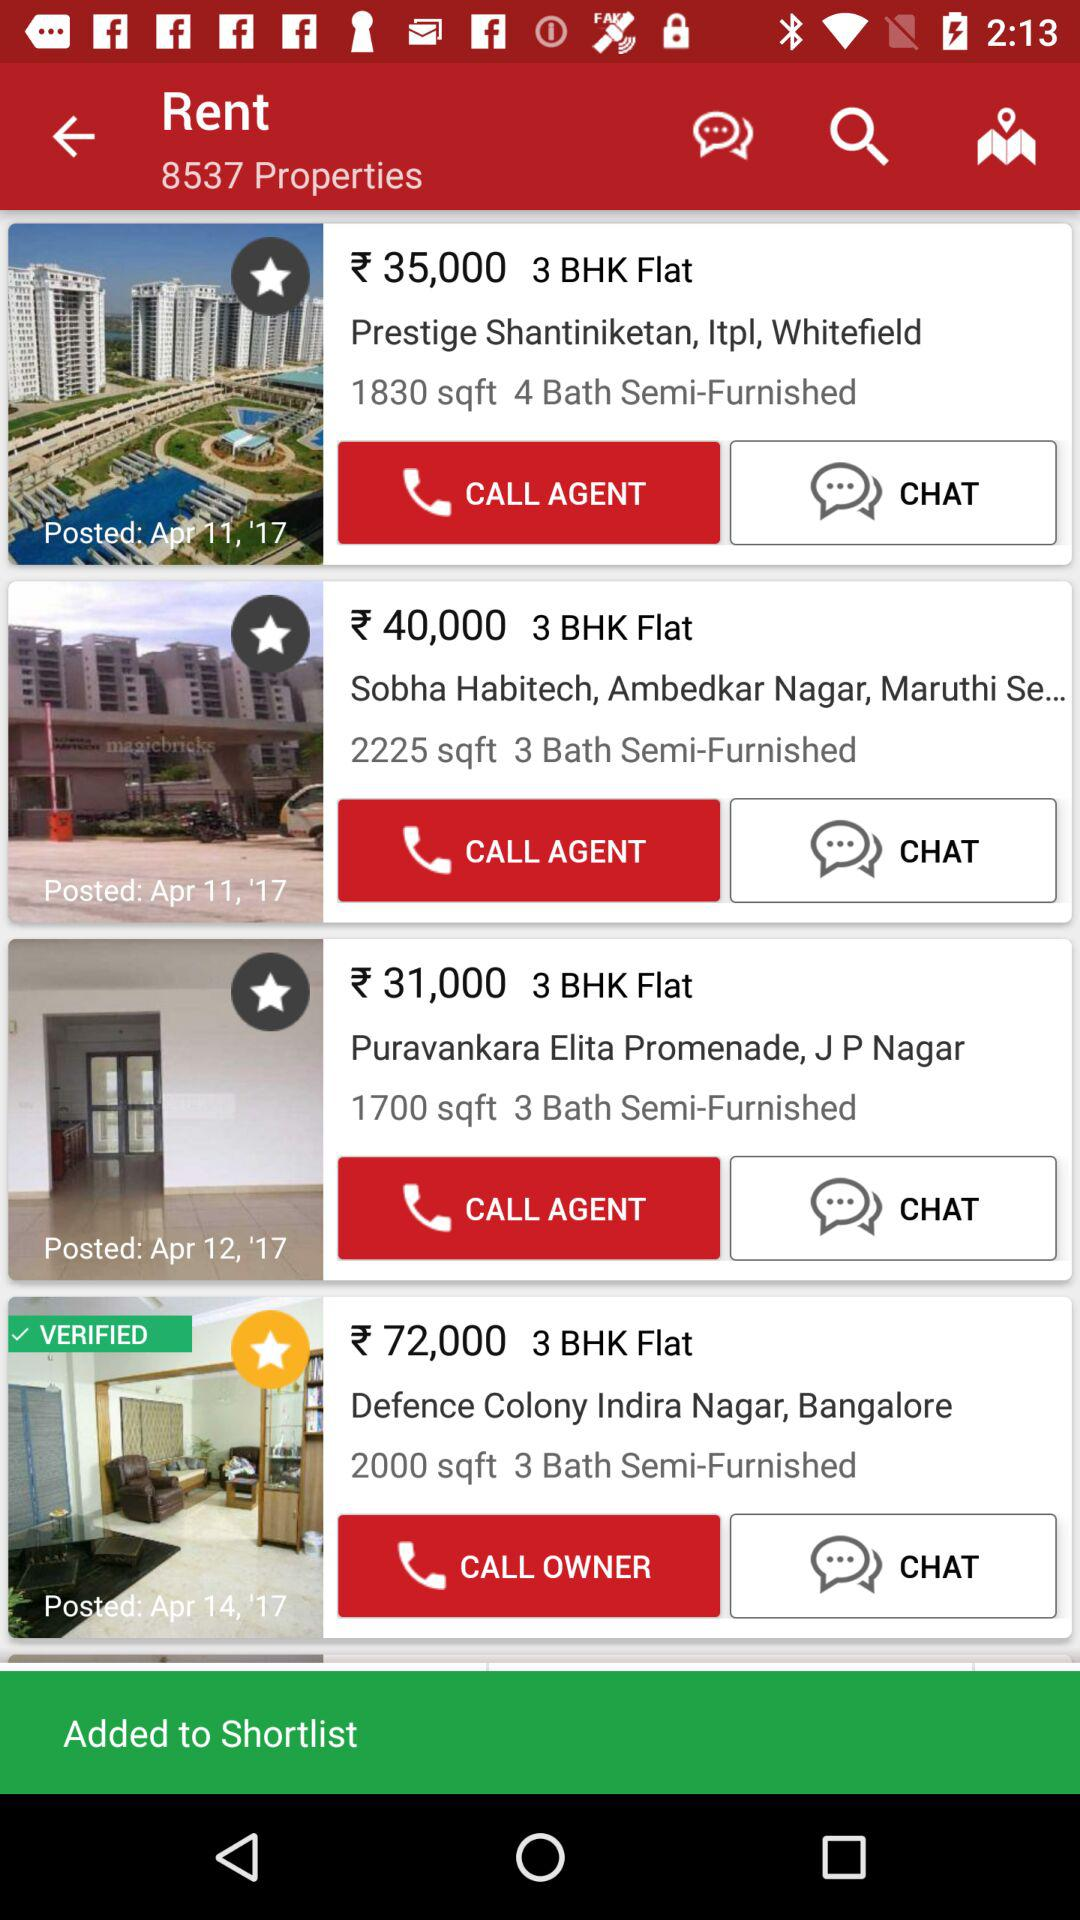How many properties are verified?
Answer the question using a single word or phrase. 1 